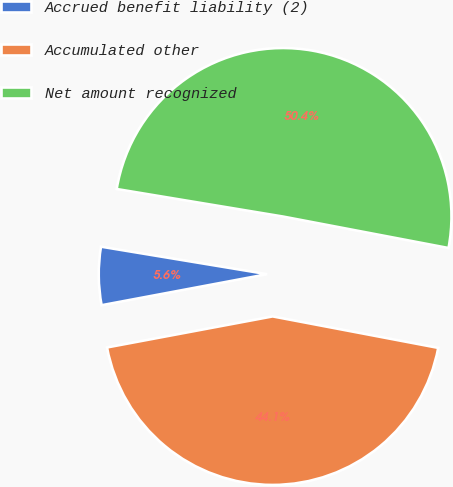<chart> <loc_0><loc_0><loc_500><loc_500><pie_chart><fcel>Accrued benefit liability (2)<fcel>Accumulated other<fcel>Net amount recognized<nl><fcel>5.56%<fcel>44.06%<fcel>50.38%<nl></chart> 